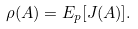<formula> <loc_0><loc_0><loc_500><loc_500>\rho ( A ) = E _ { p } [ J ( A ) ] .</formula> 